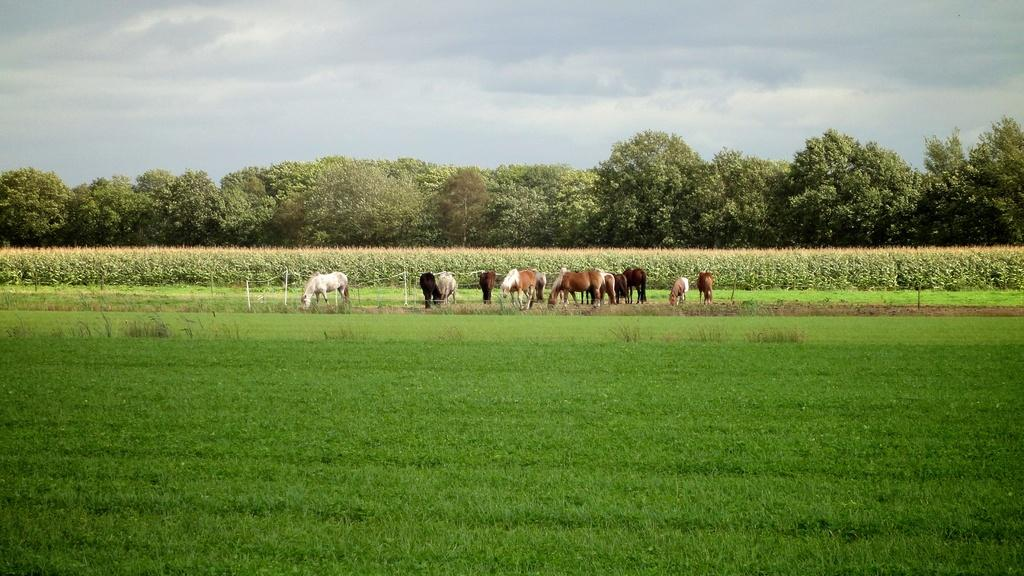What type of surface is visible in the image? There is a ground in the image. What can be found on the ground in the image? Animals and crops are present on the ground in the image. What other natural elements are present in the image? Trees are present in the image. What is visible at the top of the image? The sky is visible at the top of the image. How many stitches are used to create the pattern on the shelf in the image? There is no shelf present in the image, and therefore no pattern or stitches to count. 